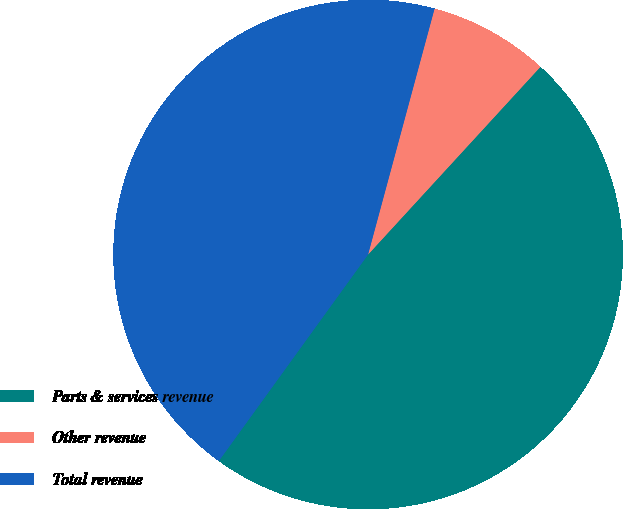Convert chart to OTSL. <chart><loc_0><loc_0><loc_500><loc_500><pie_chart><fcel>Parts & services revenue<fcel>Other revenue<fcel>Total revenue<nl><fcel>48.14%<fcel>7.62%<fcel>44.24%<nl></chart> 